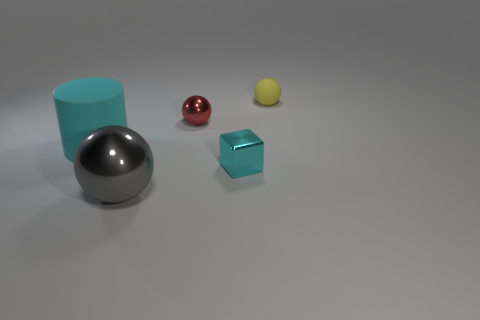Subtract 1 balls. How many balls are left? 2 Add 4 tiny matte spheres. How many objects exist? 9 Subtract all cylinders. How many objects are left? 4 Subtract all green matte spheres. Subtract all large matte cylinders. How many objects are left? 4 Add 5 tiny metallic things. How many tiny metallic things are left? 7 Add 2 cyan metallic cylinders. How many cyan metallic cylinders exist? 2 Subtract 0 brown spheres. How many objects are left? 5 